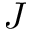<formula> <loc_0><loc_0><loc_500><loc_500>J</formula> 